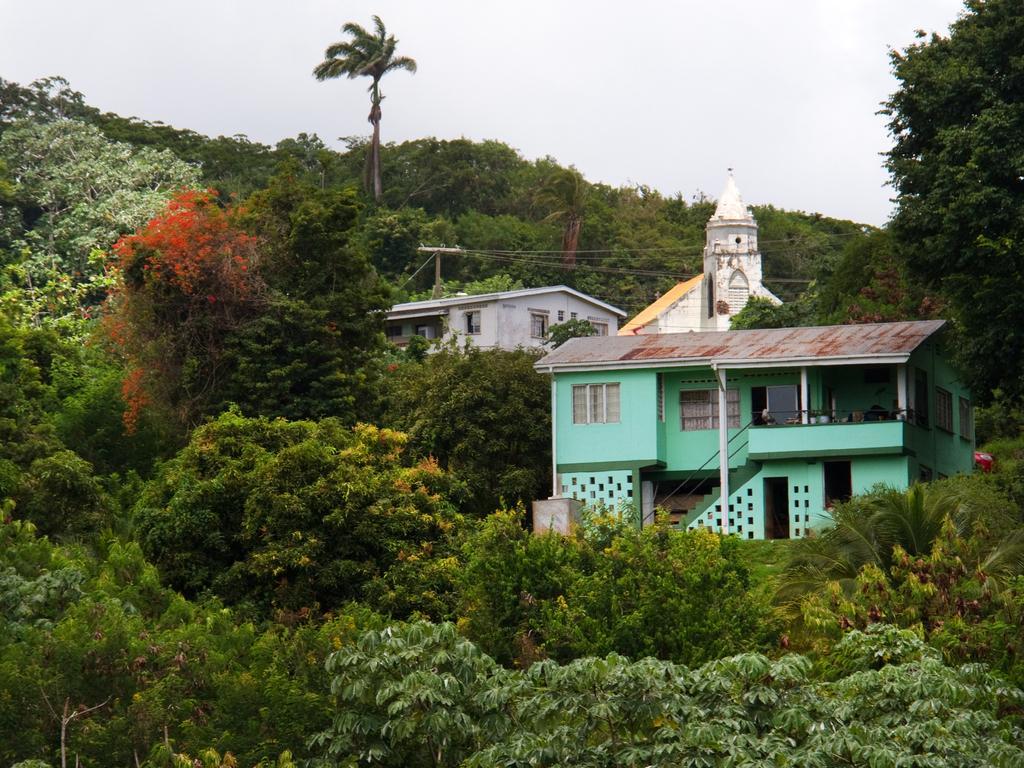In one or two sentences, can you explain what this image depicts? In this image we can see there are a few buildings and this buildings are surrounded by huge trees. In the background there is a sky. 